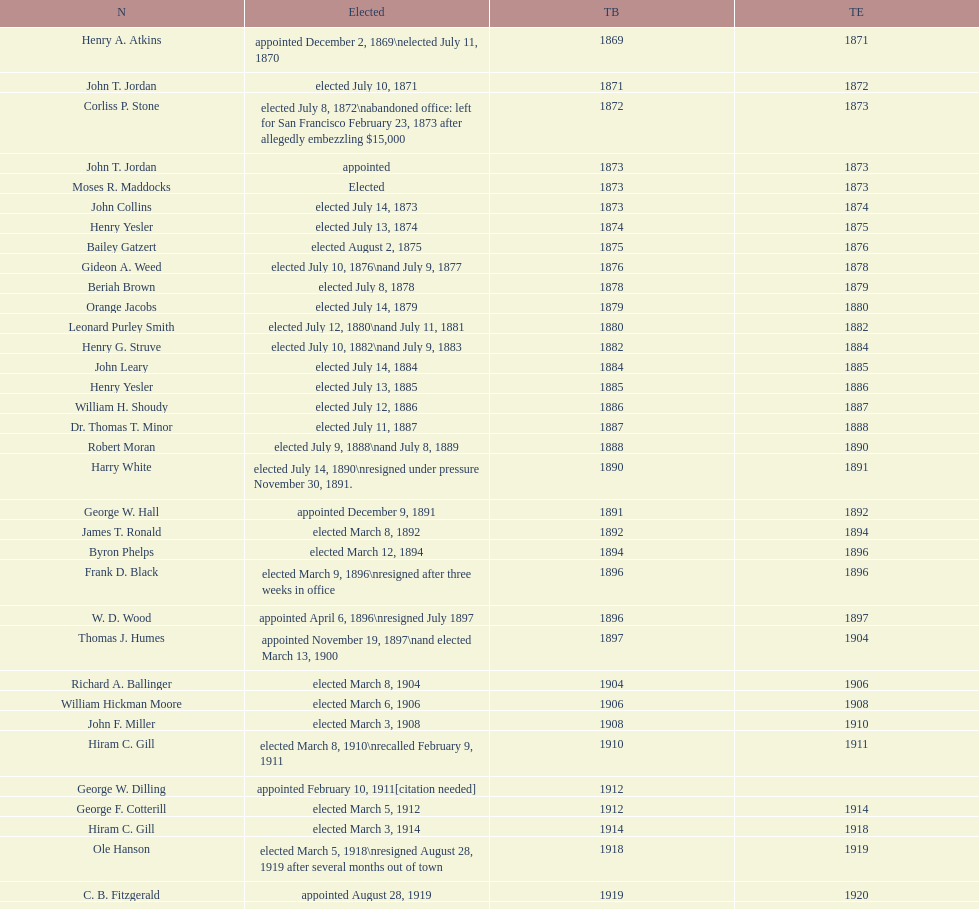How many days did robert moran serve? 365. 